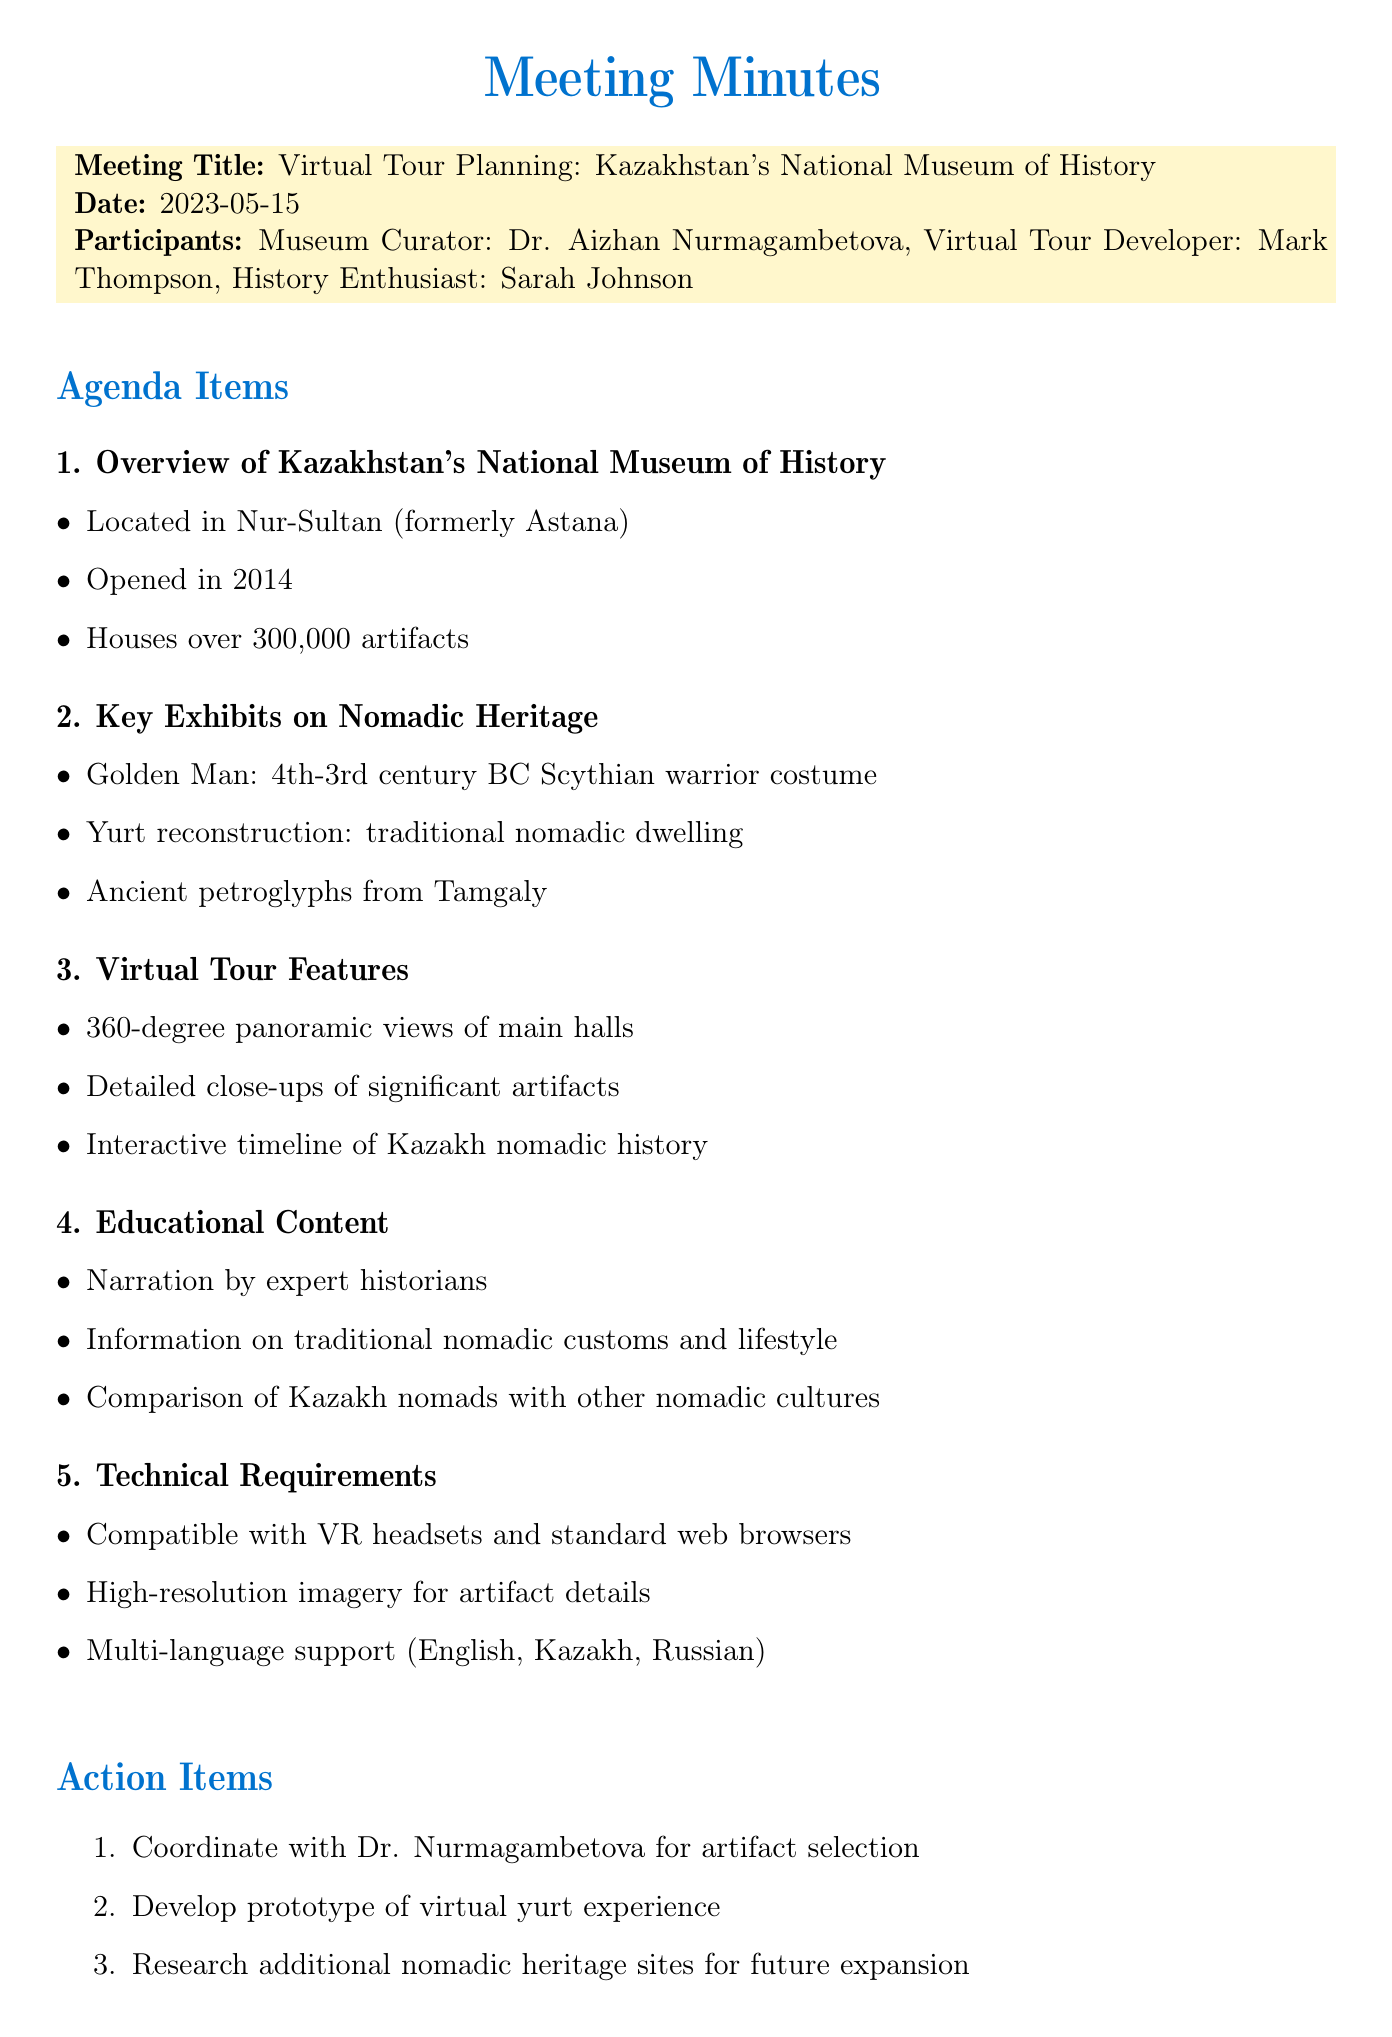What is the title of the meeting? The title of the meeting is mentioned at the beginning of the document.
Answer: Virtual Tour Planning: Kazakhstan's National Museum of History What is the location of Kazakhstan's National Museum of History? The document provides information on the location of the museum in the overview section.
Answer: Nur-Sultan How many artifacts does the museum house? The document specifies the total number of artifacts housed in the museum.
Answer: over 300,000 artifacts What significant artifact represents a Scythian warrior? The document lists key exhibits, including a significant artifact representing a Scythian warrior.
Answer: Golden Man Which traditional nomadic dwelling is reconstructed in the museum? The meeting minutes mention a specific traditional dwelling in the key exhibits section.
Answer: Yurt reconstruction What type of support will the virtual tour offer? The document states the types of support that will be included in the technical requirements.
Answer: Multi-language support (English, Kazakh, Russian) Who is coordinating for artifact selection? The action items section lists the person responsible for coordinating artifact selection.
Answer: Dr. Nurmagambetova What kind of experiences is being developed for the virtual tour? The action items mention the type of experience being developed specifically for the tour.
Answer: Virtual yurt experience 